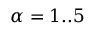<formula> <loc_0><loc_0><loc_500><loc_500>\alpha = 1 . . 5</formula> 